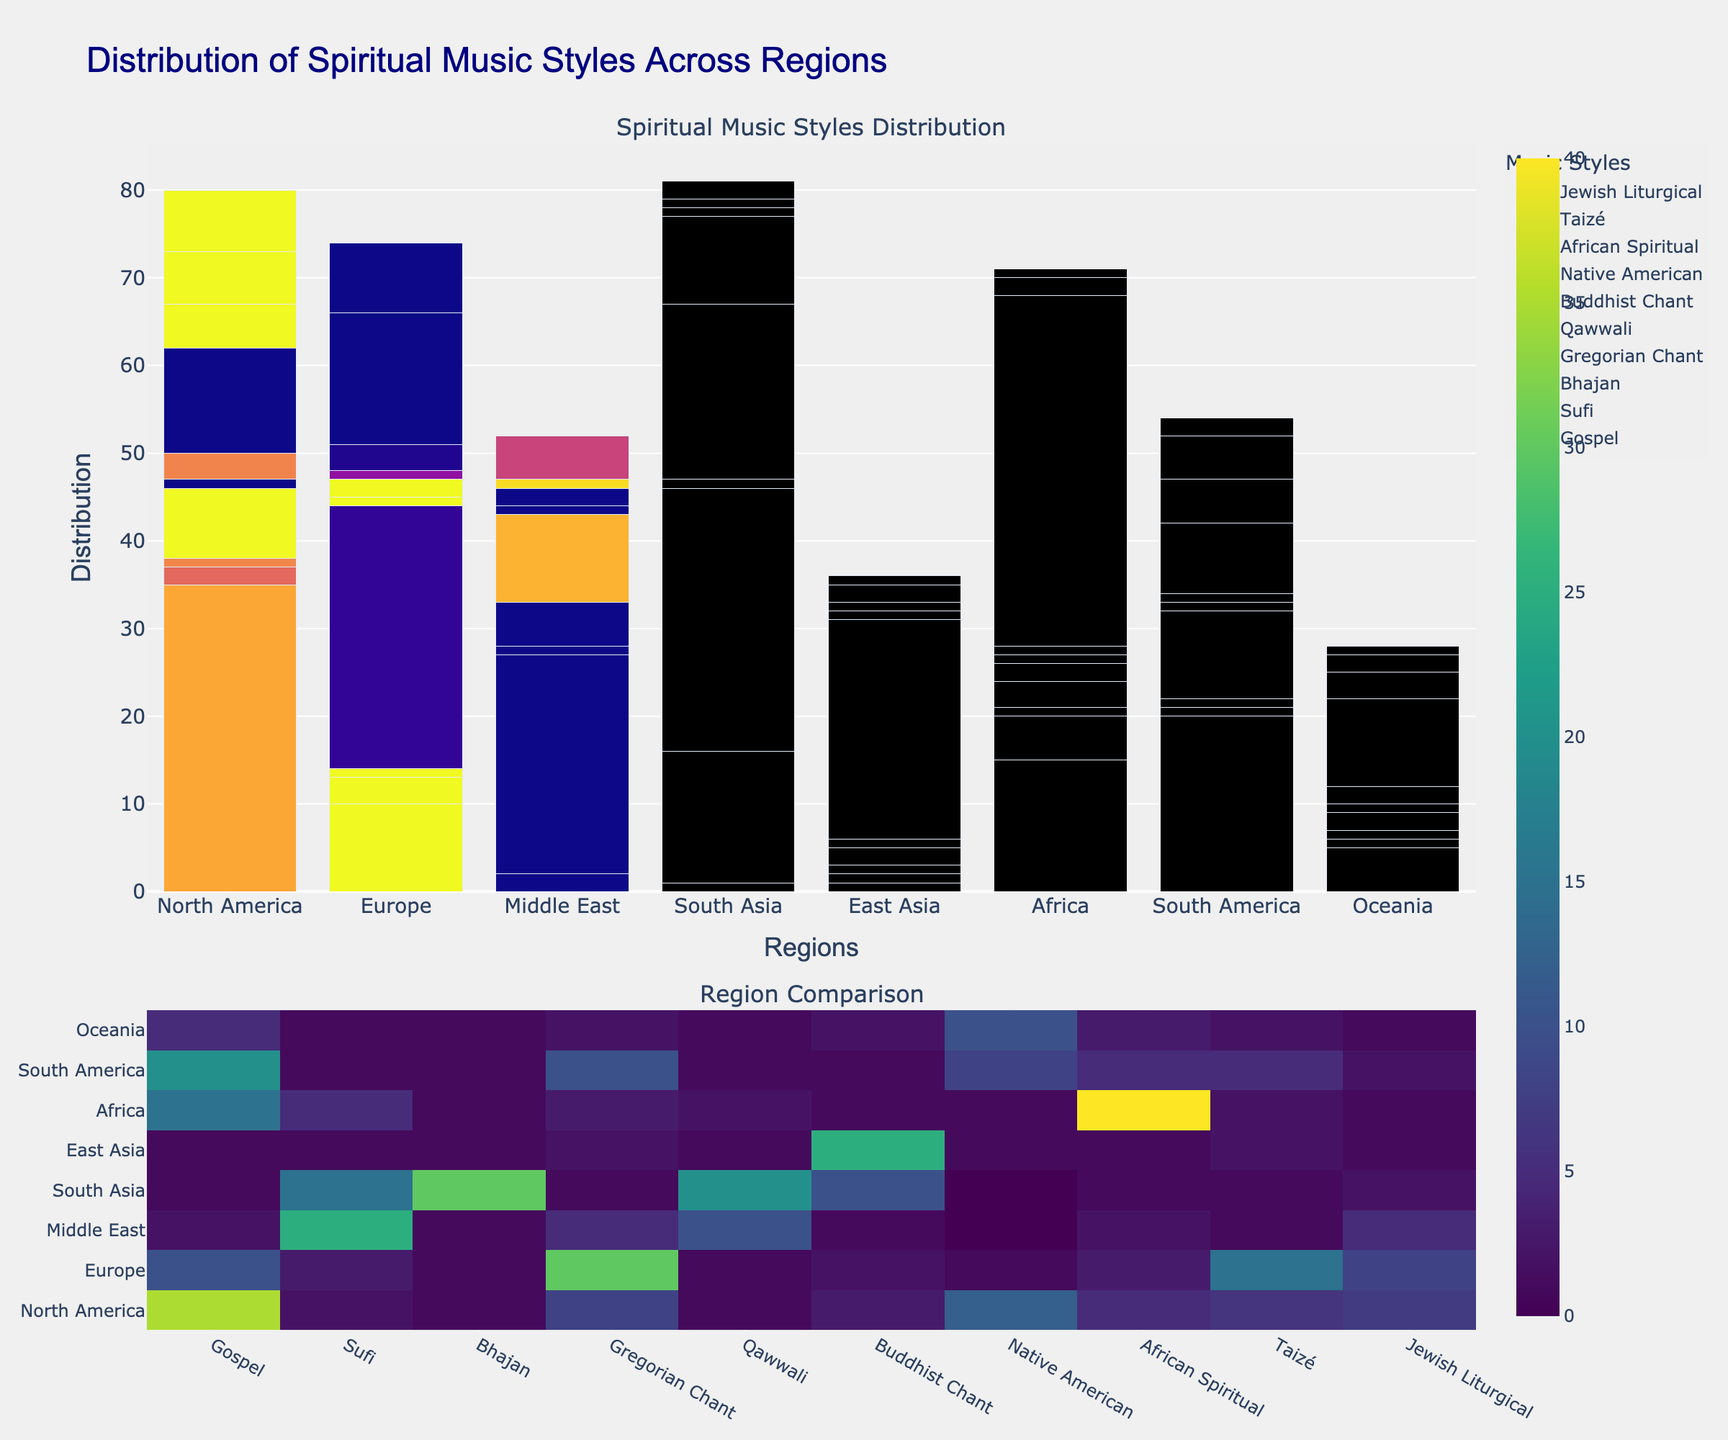which region has the largest distribution of Gospel music? By observing the height of the bars, North America has the tallest bar for Gospel music.
Answer: North America which region does Native American spiritual music appear most predominantly in? Comparing all regions, Oceania has the highest representation of Native American spiritual music.
Answer: Oceania in which region is the distribution of Bhajan music the highest? By looking at the height of the bars for Bhajan music, South Asia has the tallest bar.
Answer: South Asia which region has a higher distribution of Taizé, Europe or North America? The bar for Taizé in Europe is taller than the bar for Taizé in North America.
Answer: Europe which region shows a greater variety in music styles, North America or Africa? North America exhibits a wider range of styles compared to Africa when looking at the presence of different bars.
Answer: North America what is the combined distribution of Sufi and Qawwali music in the Middle East? Sufi music has a count of 25 and Qawwali has a count of 10 in the Middle East, thus the total is 25 + 10 = 35
Answer: 35 what is the difference in the Gospel music distribution between South America and Oceania? South America has a distribution of 20, and Oceania has a distribution of 5, the difference is 20 - 5 = 15
Answer: 15 which spiritual music style is predominantly unique to the Middle East? Sufi music has the highest value in the Middle East compared to other regions.
Answer: Sufi which region has greater overall distribution of spiritual music, Europe or South Asia? Summing up all values for Europe (10+3+1+30+1+2+1+3+15+8=74) and South Asia (1+15+30+1+20+10+0+1+1+2=81), South Asia has a higher overall distribution.
Answer: South Asia which two regions have a similar number of Buddhist Chant distributions? South Asia and East Asia both have a Buddhist Chant distribution represented by tall bars of similar height.
Answer: South Asia, East Asia 